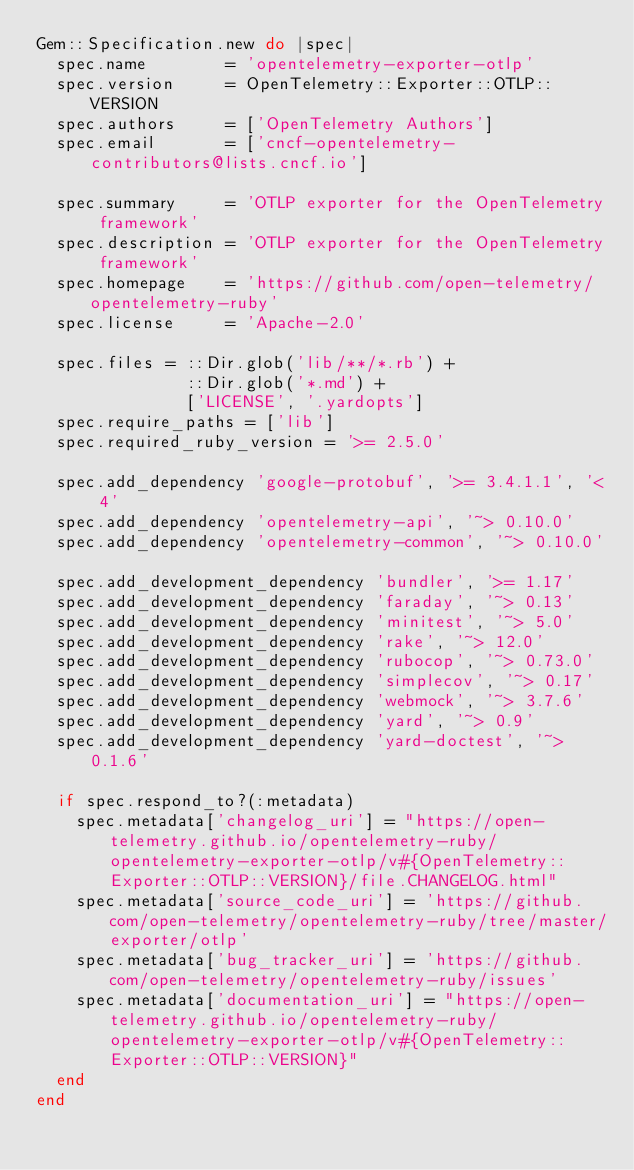<code> <loc_0><loc_0><loc_500><loc_500><_Ruby_>Gem::Specification.new do |spec|
  spec.name        = 'opentelemetry-exporter-otlp'
  spec.version     = OpenTelemetry::Exporter::OTLP::VERSION
  spec.authors     = ['OpenTelemetry Authors']
  spec.email       = ['cncf-opentelemetry-contributors@lists.cncf.io']

  spec.summary     = 'OTLP exporter for the OpenTelemetry framework'
  spec.description = 'OTLP exporter for the OpenTelemetry framework'
  spec.homepage    = 'https://github.com/open-telemetry/opentelemetry-ruby'
  spec.license     = 'Apache-2.0'

  spec.files = ::Dir.glob('lib/**/*.rb') +
               ::Dir.glob('*.md') +
               ['LICENSE', '.yardopts']
  spec.require_paths = ['lib']
  spec.required_ruby_version = '>= 2.5.0'

  spec.add_dependency 'google-protobuf', '>= 3.4.1.1', '< 4'
  spec.add_dependency 'opentelemetry-api', '~> 0.10.0'
  spec.add_dependency 'opentelemetry-common', '~> 0.10.0'

  spec.add_development_dependency 'bundler', '>= 1.17'
  spec.add_development_dependency 'faraday', '~> 0.13'
  spec.add_development_dependency 'minitest', '~> 5.0'
  spec.add_development_dependency 'rake', '~> 12.0'
  spec.add_development_dependency 'rubocop', '~> 0.73.0'
  spec.add_development_dependency 'simplecov', '~> 0.17'
  spec.add_development_dependency 'webmock', '~> 3.7.6'
  spec.add_development_dependency 'yard', '~> 0.9'
  spec.add_development_dependency 'yard-doctest', '~> 0.1.6'

  if spec.respond_to?(:metadata)
    spec.metadata['changelog_uri'] = "https://open-telemetry.github.io/opentelemetry-ruby/opentelemetry-exporter-otlp/v#{OpenTelemetry::Exporter::OTLP::VERSION}/file.CHANGELOG.html"
    spec.metadata['source_code_uri'] = 'https://github.com/open-telemetry/opentelemetry-ruby/tree/master/exporter/otlp'
    spec.metadata['bug_tracker_uri'] = 'https://github.com/open-telemetry/opentelemetry-ruby/issues'
    spec.metadata['documentation_uri'] = "https://open-telemetry.github.io/opentelemetry-ruby/opentelemetry-exporter-otlp/v#{OpenTelemetry::Exporter::OTLP::VERSION}"
  end
end
</code> 